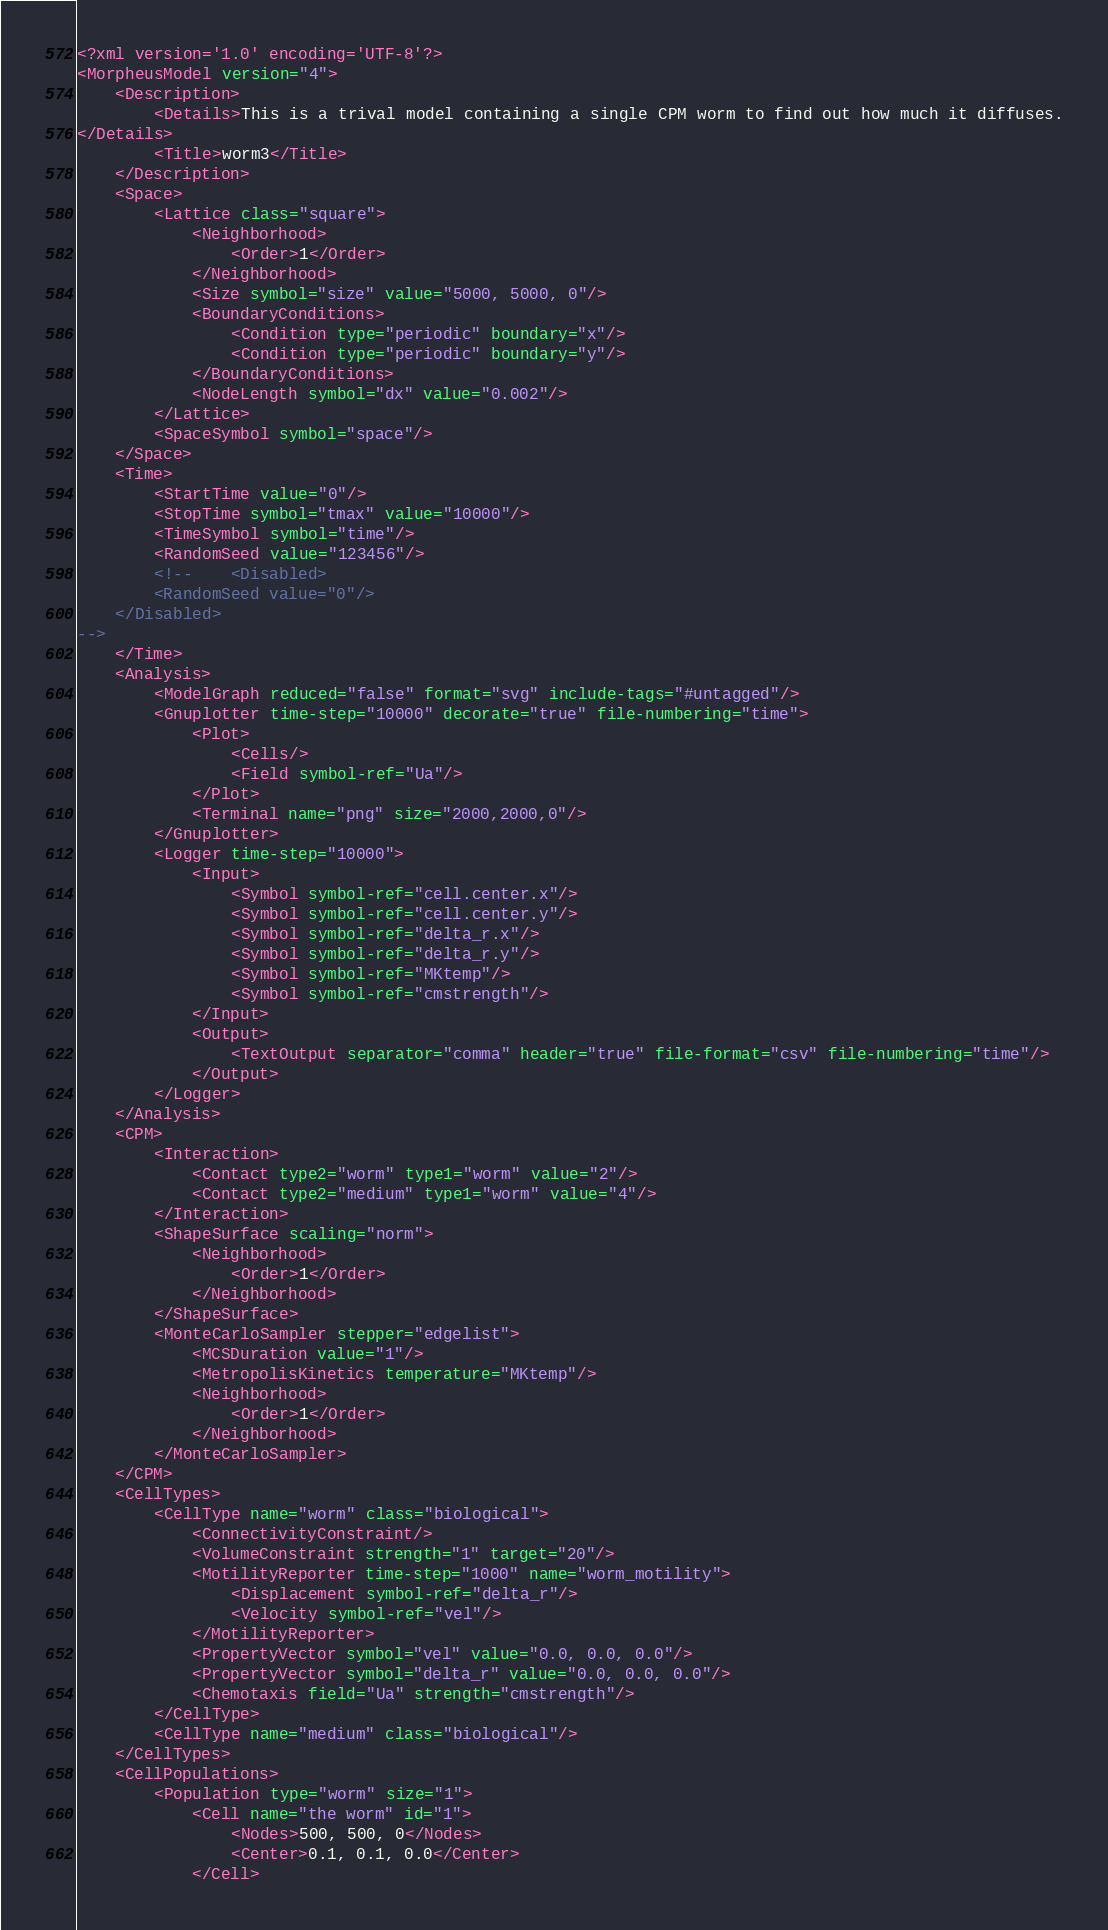Convert code to text. <code><loc_0><loc_0><loc_500><loc_500><_XML_><?xml version='1.0' encoding='UTF-8'?>
<MorpheusModel version="4">
    <Description>
        <Details>This is a trival model containing a single CPM worm to find out how much it diffuses.
</Details>
        <Title>worm3</Title>
    </Description>
    <Space>
        <Lattice class="square">
            <Neighborhood>
                <Order>1</Order>
            </Neighborhood>
            <Size symbol="size" value="5000, 5000, 0"/>
            <BoundaryConditions>
                <Condition type="periodic" boundary="x"/>
                <Condition type="periodic" boundary="y"/>
            </BoundaryConditions>
            <NodeLength symbol="dx" value="0.002"/>
        </Lattice>
        <SpaceSymbol symbol="space"/>
    </Space>
    <Time>
        <StartTime value="0"/>
        <StopTime symbol="tmax" value="10000"/>
        <TimeSymbol symbol="time"/>
        <RandomSeed value="123456"/>
        <!--    <Disabled>
        <RandomSeed value="0"/>
    </Disabled>
-->
    </Time>
    <Analysis>
        <ModelGraph reduced="false" format="svg" include-tags="#untagged"/>
        <Gnuplotter time-step="10000" decorate="true" file-numbering="time">
            <Plot>
                <Cells/>
                <Field symbol-ref="Ua"/>
            </Plot>
            <Terminal name="png" size="2000,2000,0"/>
        </Gnuplotter>
        <Logger time-step="10000">
            <Input>
                <Symbol symbol-ref="cell.center.x"/>
                <Symbol symbol-ref="cell.center.y"/>
                <Symbol symbol-ref="delta_r.x"/>
                <Symbol symbol-ref="delta_r.y"/>
                <Symbol symbol-ref="MKtemp"/>
                <Symbol symbol-ref="cmstrength"/>
            </Input>
            <Output>
                <TextOutput separator="comma" header="true" file-format="csv" file-numbering="time"/>
            </Output>
        </Logger>
    </Analysis>
    <CPM>
        <Interaction>
            <Contact type2="worm" type1="worm" value="2"/>
            <Contact type2="medium" type1="worm" value="4"/>
        </Interaction>
        <ShapeSurface scaling="norm">
            <Neighborhood>
                <Order>1</Order>
            </Neighborhood>
        </ShapeSurface>
        <MonteCarloSampler stepper="edgelist">
            <MCSDuration value="1"/>
            <MetropolisKinetics temperature="MKtemp"/>
            <Neighborhood>
                <Order>1</Order>
            </Neighborhood>
        </MonteCarloSampler>
    </CPM>
    <CellTypes>
        <CellType name="worm" class="biological">
            <ConnectivityConstraint/>
            <VolumeConstraint strength="1" target="20"/>
            <MotilityReporter time-step="1000" name="worm_motility">
                <Displacement symbol-ref="delta_r"/>
                <Velocity symbol-ref="vel"/>
            </MotilityReporter>
            <PropertyVector symbol="vel" value="0.0, 0.0, 0.0"/>
            <PropertyVector symbol="delta_r" value="0.0, 0.0, 0.0"/>
            <Chemotaxis field="Ua" strength="cmstrength"/>
        </CellType>
        <CellType name="medium" class="biological"/>
    </CellTypes>
    <CellPopulations>
        <Population type="worm" size="1">
            <Cell name="the worm" id="1">
                <Nodes>500, 500, 0</Nodes>
                <Center>0.1, 0.1, 0.0</Center>
            </Cell></code> 